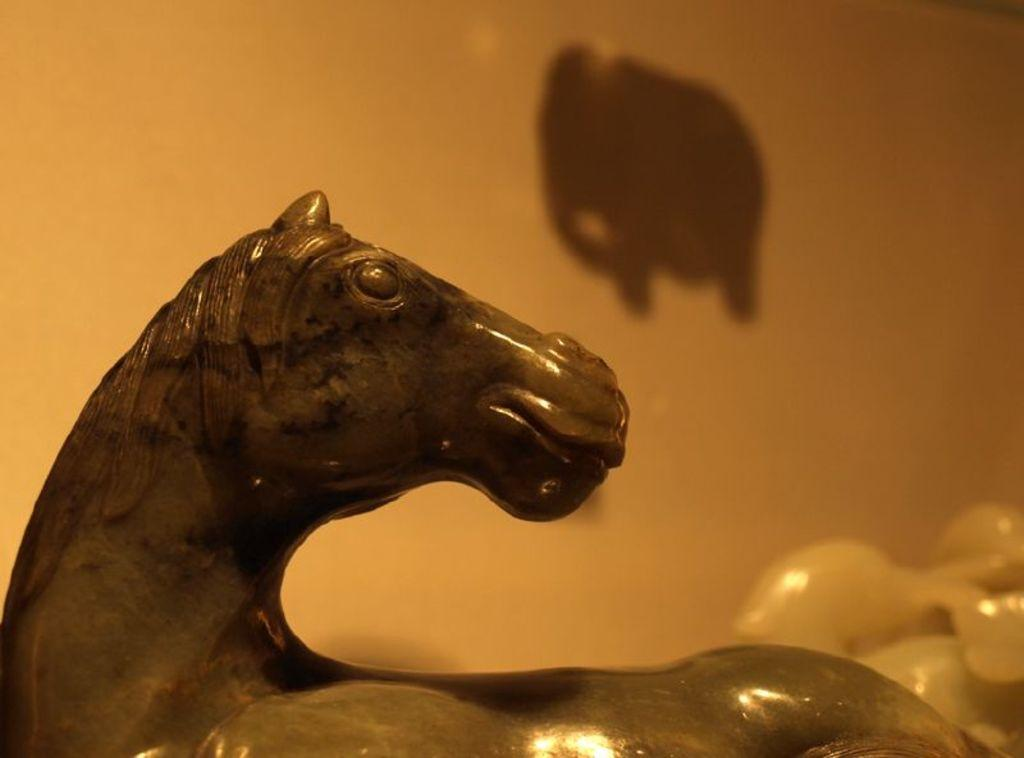What type of toy is present in the image? There is a horse toy in the image. What can be seen in the background of the image? There is a wall in the background of the image. What type of scissors can be seen cutting the horse toy in the image? There are no scissors present in the image, nor is the horse toy being cut. 